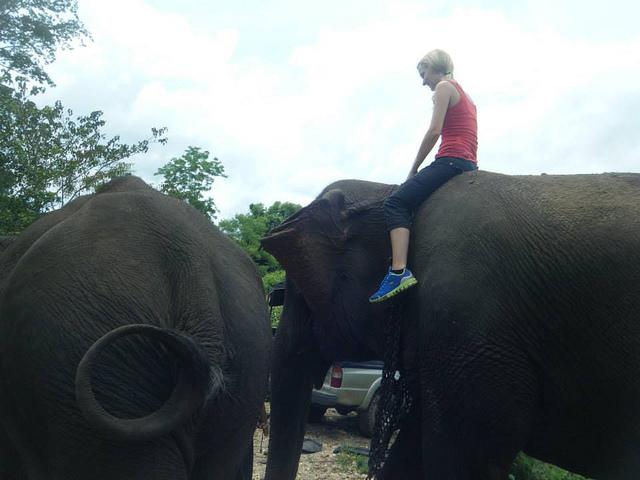Is there a car in the picture?
Answer briefly. Yes. Is this a wild animal?
Answer briefly. No. What is she riding on?
Give a very brief answer. Elephant. How many people are in the picture?
Write a very short answer. 1. Who is riding the elephant in front?
Write a very short answer. Girl. How many elephants are there?
Quick response, please. 2. 